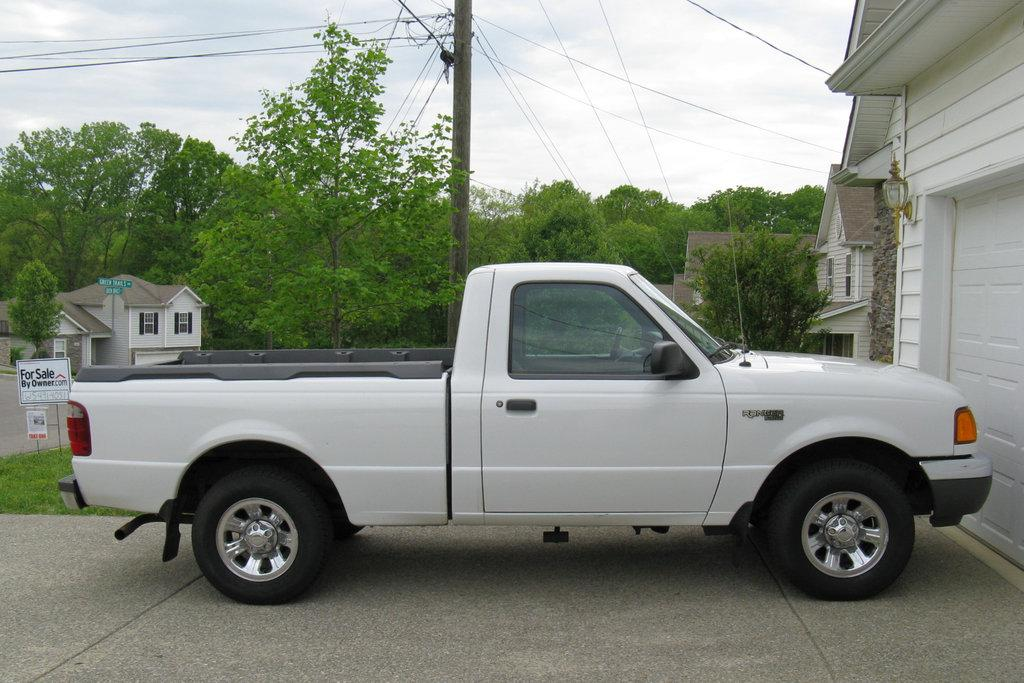What is the main subject of the image? There is a vehicle in the image. Can you describe the color of the vehicle? The vehicle is white. What can be seen in the background of the image? There are houses and trees in the background of the image. What colors are the houses and trees? The houses are white, and the trees are green. What else is visible in the image? The sky is visible in the image. What color is the sky? The sky is white. What type of plantation is visible in the image? There is no plantation present in the image. How many police officers are visible in the image? There are no police officers present in the image. 